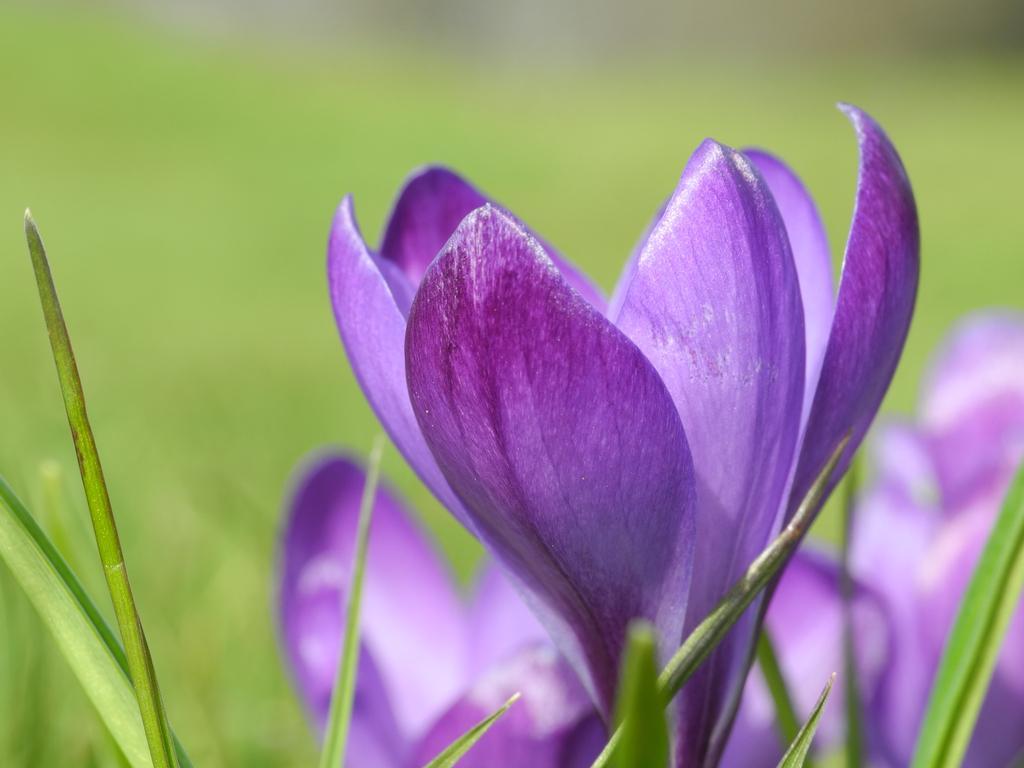Describe this image in one or two sentences. This is a zoomed in picture. In the foreground we can see the flowers and leaves of a plant. The background of the image is blurry and the background is green in color. 